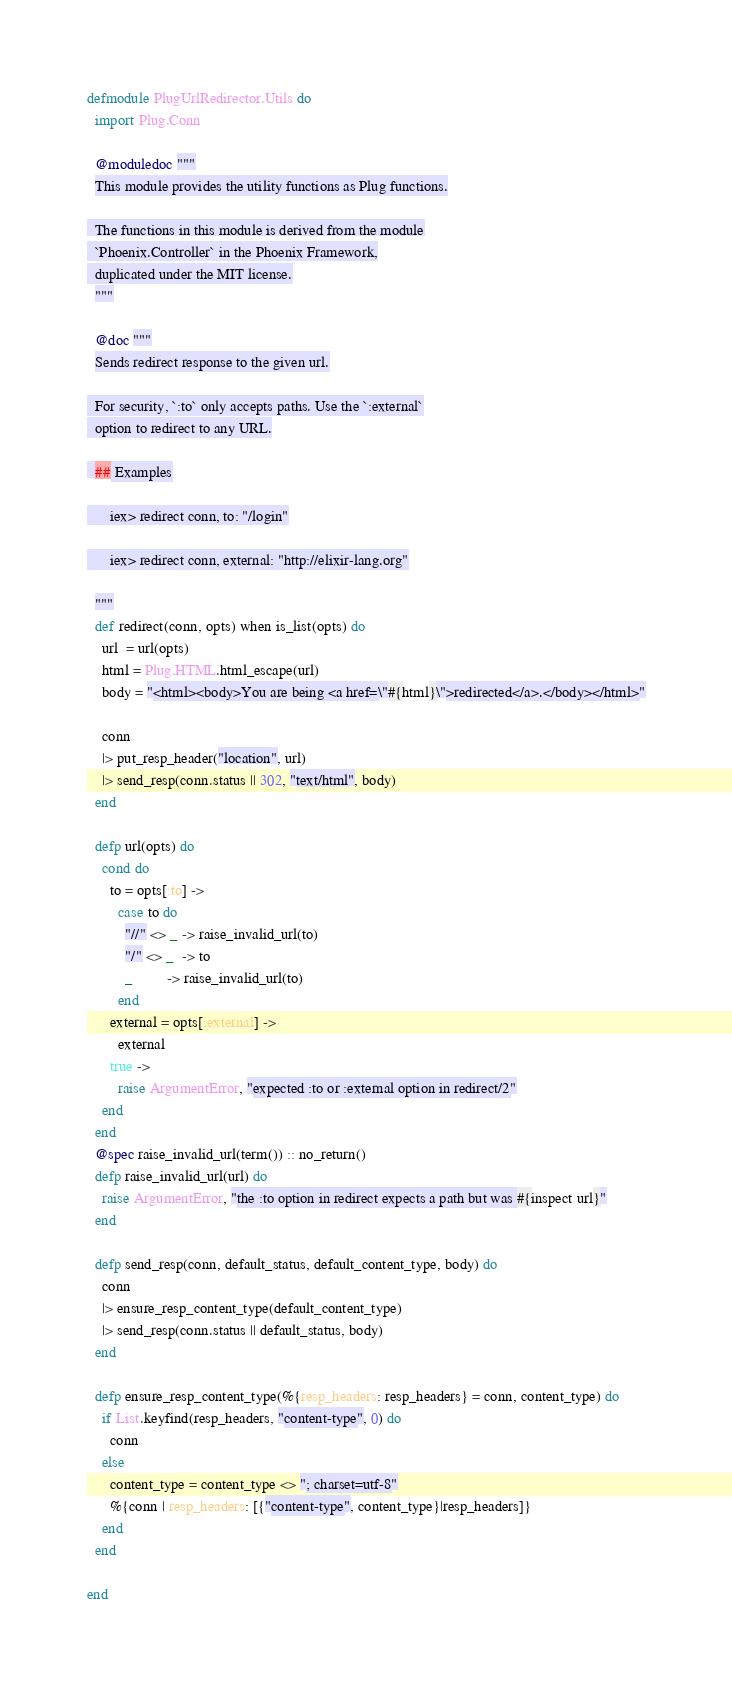Convert code to text. <code><loc_0><loc_0><loc_500><loc_500><_Elixir_>defmodule PlugUrlRedirector.Utils do
  import Plug.Conn

  @moduledoc """
  This module provides the utility functions as Plug functions.

  The functions in this module is derived from the module
  `Phoenix.Controller` in the Phoenix Framework,
  duplicated under the MIT license.
  """

  @doc """
  Sends redirect response to the given url.

  For security, `:to` only accepts paths. Use the `:external`
  option to redirect to any URL.

  ## Examples

      iex> redirect conn, to: "/login"

      iex> redirect conn, external: "http://elixir-lang.org"

  """
  def redirect(conn, opts) when is_list(opts) do
    url  = url(opts)
    html = Plug.HTML.html_escape(url)
    body = "<html><body>You are being <a href=\"#{html}\">redirected</a>.</body></html>"

    conn
    |> put_resp_header("location", url)
    |> send_resp(conn.status || 302, "text/html", body)
  end

  defp url(opts) do
    cond do
      to = opts[:to] ->
        case to do
          "//" <> _ -> raise_invalid_url(to)
          "/" <> _  -> to
          _         -> raise_invalid_url(to)
        end
      external = opts[:external] ->
        external
      true ->
        raise ArgumentError, "expected :to or :external option in redirect/2"
    end
  end
  @spec raise_invalid_url(term()) :: no_return()
  defp raise_invalid_url(url) do
    raise ArgumentError, "the :to option in redirect expects a path but was #{inspect url}"
  end

  defp send_resp(conn, default_status, default_content_type, body) do
    conn
    |> ensure_resp_content_type(default_content_type)
    |> send_resp(conn.status || default_status, body)
  end

  defp ensure_resp_content_type(%{resp_headers: resp_headers} = conn, content_type) do
    if List.keyfind(resp_headers, "content-type", 0) do
      conn
    else
      content_type = content_type <> "; charset=utf-8"
      %{conn | resp_headers: [{"content-type", content_type}|resp_headers]}
    end
  end

end
</code> 